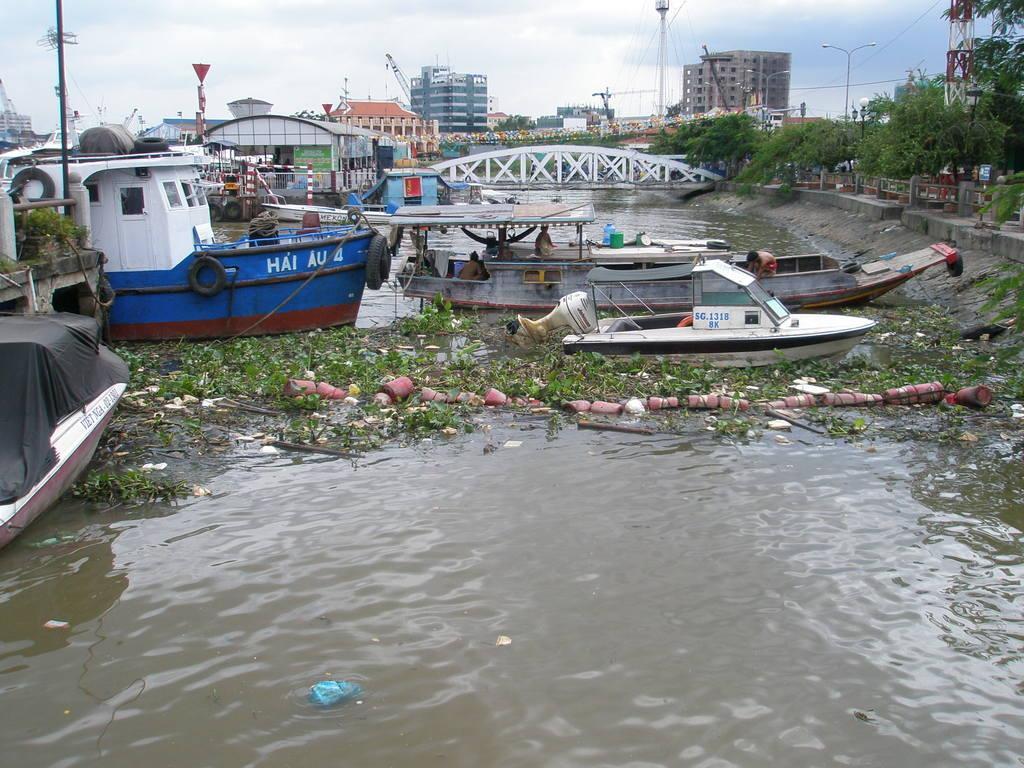Please provide a concise description of this image. In this picture we can see so many ships in a lake and few buildings and trees. 